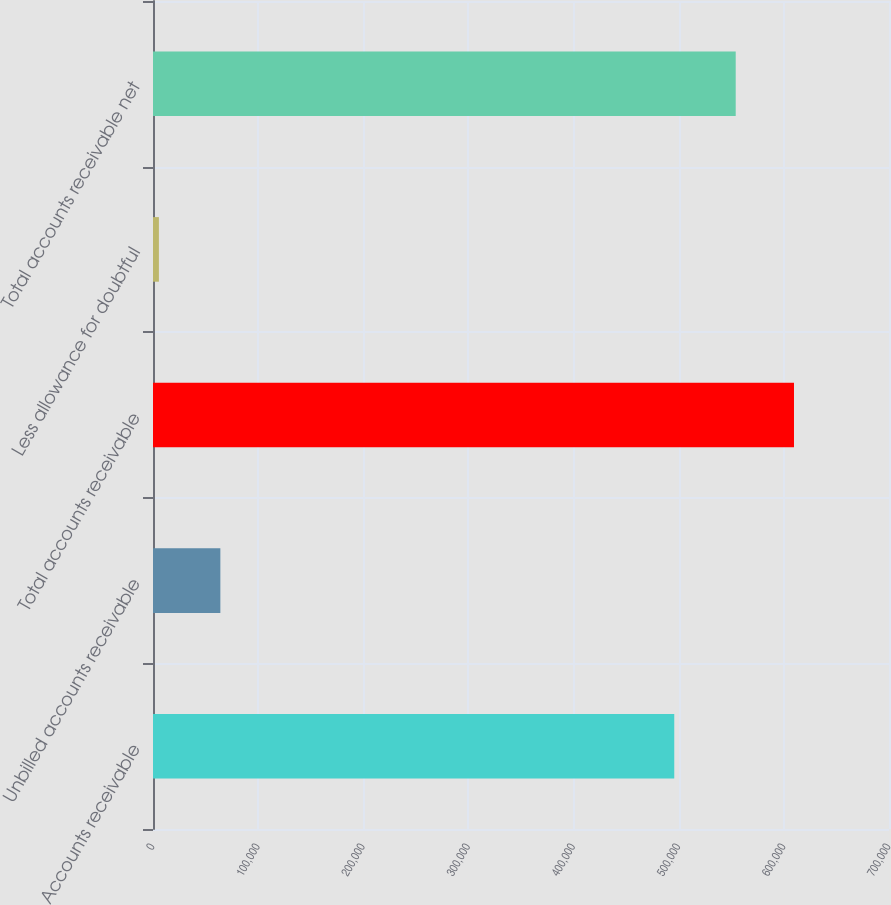Convert chart to OTSL. <chart><loc_0><loc_0><loc_500><loc_500><bar_chart><fcel>Accounts receivable<fcel>Unbilled accounts receivable<fcel>Total accounts receivable<fcel>Less allowance for doubtful<fcel>Total accounts receivable net<nl><fcel>495763<fcel>64067<fcel>609639<fcel>5613<fcel>554217<nl></chart> 